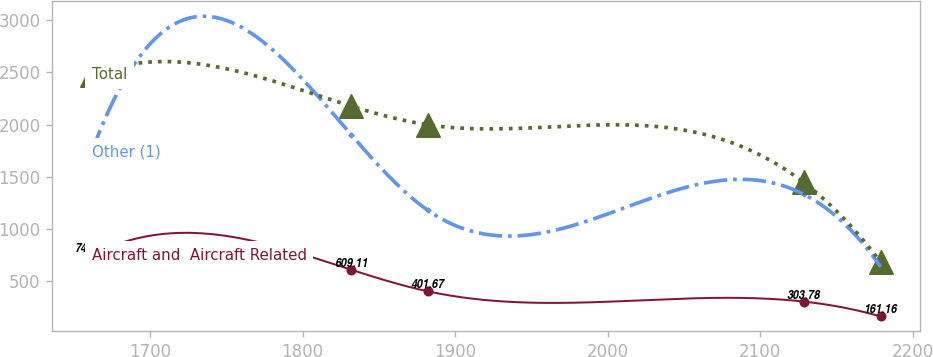Convert chart to OTSL. <chart><loc_0><loc_0><loc_500><loc_500><line_chart><ecel><fcel>Other (1)<fcel>Aircraft and  Aircraft Related<fcel>Total<nl><fcel>1661.72<fcel>1736.62<fcel>746.66<fcel>2477.28<nl><fcel>1831.9<fcel>1903.87<fcel>609.11<fcel>2177.89<nl><fcel>1882.26<fcel>1177.46<fcel>401.67<fcel>1998.34<nl><fcel>2128.62<fcel>1331.83<fcel>303.78<fcel>1445.39<nl><fcel>2178.98<fcel>637.91<fcel>161.16<fcel>681.75<nl></chart> 